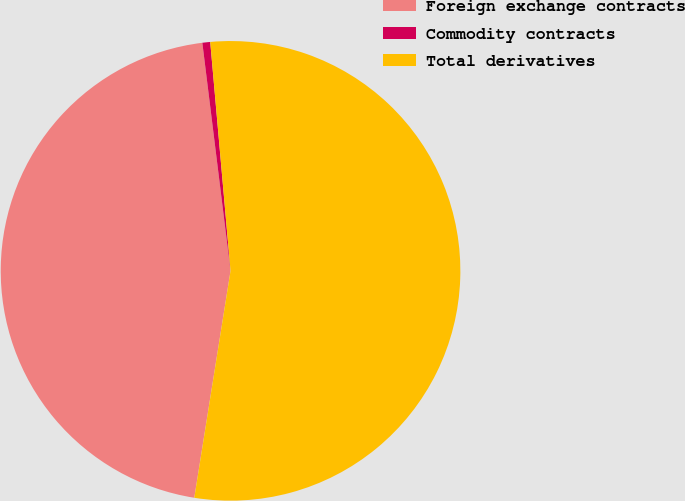Convert chart. <chart><loc_0><loc_0><loc_500><loc_500><pie_chart><fcel>Foreign exchange contracts<fcel>Commodity contracts<fcel>Total derivatives<nl><fcel>45.52%<fcel>0.55%<fcel>53.93%<nl></chart> 